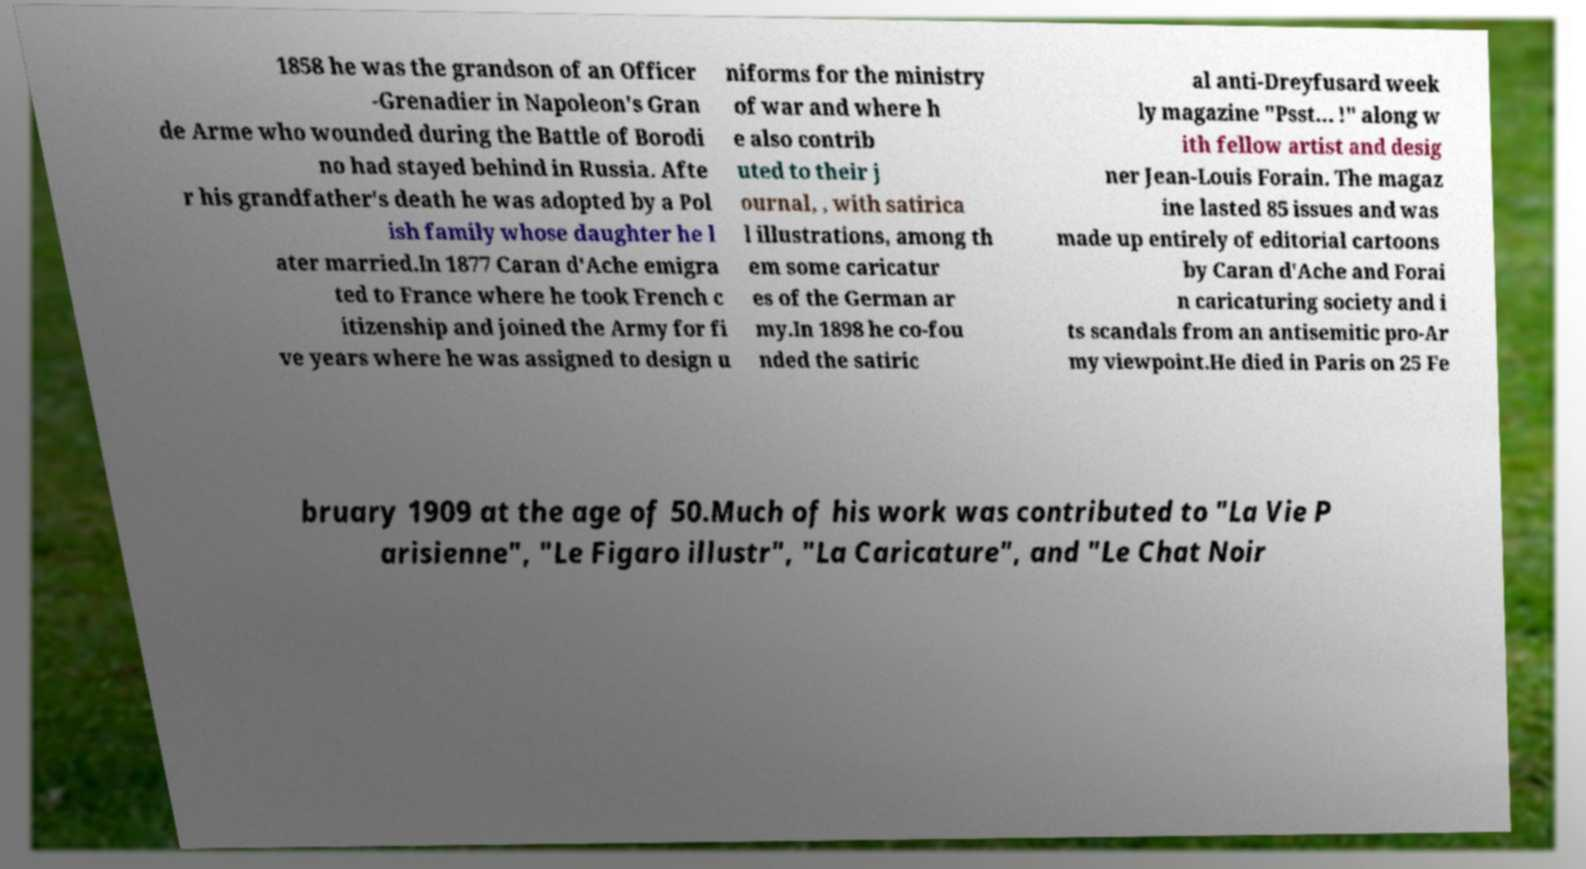Could you extract and type out the text from this image? 1858 he was the grandson of an Officer -Grenadier in Napoleon's Gran de Arme who wounded during the Battle of Borodi no had stayed behind in Russia. Afte r his grandfather's death he was adopted by a Pol ish family whose daughter he l ater married.In 1877 Caran d'Ache emigra ted to France where he took French c itizenship and joined the Army for fi ve years where he was assigned to design u niforms for the ministry of war and where h e also contrib uted to their j ournal, , with satirica l illustrations, among th em some caricatur es of the German ar my.In 1898 he co-fou nded the satiric al anti-Dreyfusard week ly magazine "Psst… !" along w ith fellow artist and desig ner Jean-Louis Forain. The magaz ine lasted 85 issues and was made up entirely of editorial cartoons by Caran d'Ache and Forai n caricaturing society and i ts scandals from an antisemitic pro-Ar my viewpoint.He died in Paris on 25 Fe bruary 1909 at the age of 50.Much of his work was contributed to "La Vie P arisienne", "Le Figaro illustr", "La Caricature", and "Le Chat Noir 